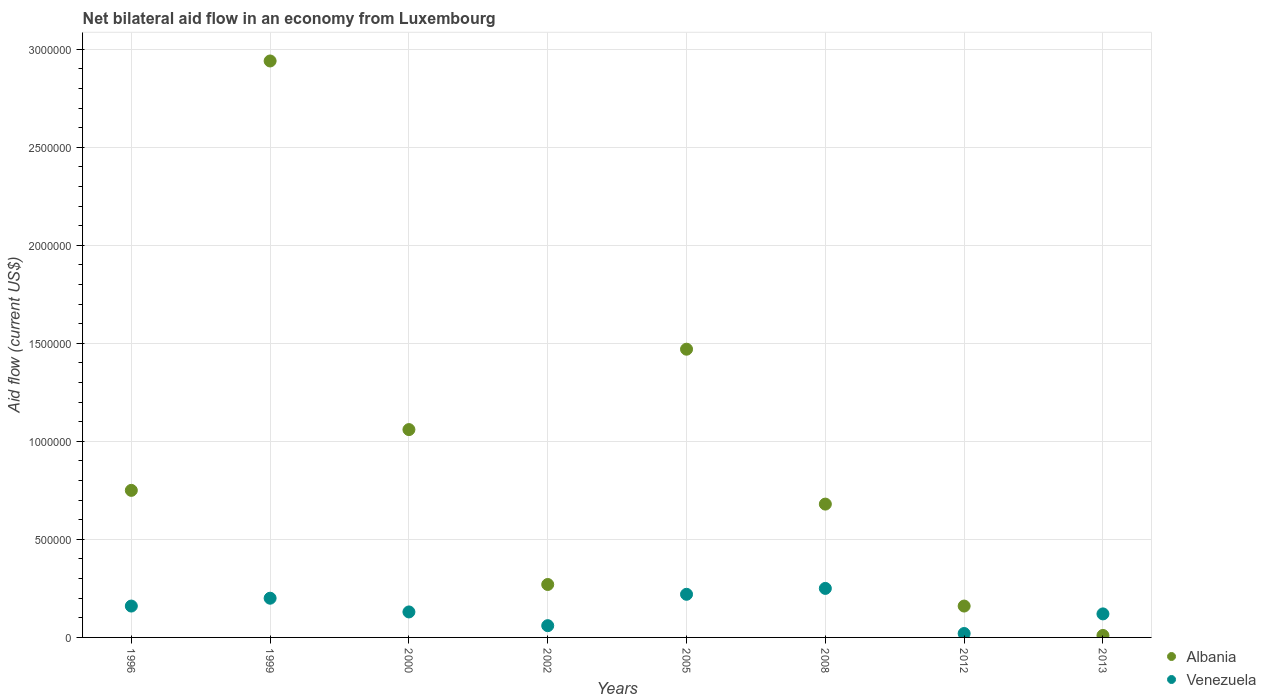How many different coloured dotlines are there?
Offer a very short reply. 2. What is the net bilateral aid flow in Venezuela in 2000?
Offer a terse response. 1.30e+05. Across all years, what is the maximum net bilateral aid flow in Albania?
Offer a terse response. 2.94e+06. In which year was the net bilateral aid flow in Venezuela minimum?
Your answer should be very brief. 2012. What is the total net bilateral aid flow in Venezuela in the graph?
Offer a very short reply. 1.16e+06. What is the difference between the net bilateral aid flow in Albania in 1999 and that in 2013?
Keep it short and to the point. 2.93e+06. What is the average net bilateral aid flow in Venezuela per year?
Make the answer very short. 1.45e+05. In the year 2005, what is the difference between the net bilateral aid flow in Venezuela and net bilateral aid flow in Albania?
Your response must be concise. -1.25e+06. What is the ratio of the net bilateral aid flow in Albania in 1999 to that in 2000?
Your response must be concise. 2.77. Is the net bilateral aid flow in Venezuela in 2002 less than that in 2008?
Ensure brevity in your answer.  Yes. What is the difference between the highest and the second highest net bilateral aid flow in Venezuela?
Provide a short and direct response. 3.00e+04. In how many years, is the net bilateral aid flow in Venezuela greater than the average net bilateral aid flow in Venezuela taken over all years?
Offer a very short reply. 4. Is the sum of the net bilateral aid flow in Venezuela in 2008 and 2012 greater than the maximum net bilateral aid flow in Albania across all years?
Offer a very short reply. No. Does the net bilateral aid flow in Albania monotonically increase over the years?
Give a very brief answer. No. Is the net bilateral aid flow in Venezuela strictly greater than the net bilateral aid flow in Albania over the years?
Make the answer very short. No. Is the net bilateral aid flow in Albania strictly less than the net bilateral aid flow in Venezuela over the years?
Your answer should be very brief. No. Are the values on the major ticks of Y-axis written in scientific E-notation?
Your answer should be compact. No. What is the title of the graph?
Offer a terse response. Net bilateral aid flow in an economy from Luxembourg. Does "Korea (Democratic)" appear as one of the legend labels in the graph?
Your answer should be compact. No. What is the label or title of the X-axis?
Make the answer very short. Years. What is the Aid flow (current US$) in Albania in 1996?
Ensure brevity in your answer.  7.50e+05. What is the Aid flow (current US$) in Venezuela in 1996?
Keep it short and to the point. 1.60e+05. What is the Aid flow (current US$) of Albania in 1999?
Your response must be concise. 2.94e+06. What is the Aid flow (current US$) in Venezuela in 1999?
Give a very brief answer. 2.00e+05. What is the Aid flow (current US$) of Albania in 2000?
Provide a short and direct response. 1.06e+06. What is the Aid flow (current US$) in Venezuela in 2000?
Make the answer very short. 1.30e+05. What is the Aid flow (current US$) of Venezuela in 2002?
Provide a succinct answer. 6.00e+04. What is the Aid flow (current US$) of Albania in 2005?
Your answer should be compact. 1.47e+06. What is the Aid flow (current US$) of Albania in 2008?
Give a very brief answer. 6.80e+05. What is the Aid flow (current US$) in Albania in 2012?
Make the answer very short. 1.60e+05. What is the Aid flow (current US$) of Venezuela in 2012?
Ensure brevity in your answer.  2.00e+04. What is the Aid flow (current US$) of Albania in 2013?
Your response must be concise. 10000. What is the Aid flow (current US$) of Venezuela in 2013?
Your answer should be very brief. 1.20e+05. Across all years, what is the maximum Aid flow (current US$) in Albania?
Provide a short and direct response. 2.94e+06. Across all years, what is the minimum Aid flow (current US$) in Albania?
Offer a terse response. 10000. What is the total Aid flow (current US$) of Albania in the graph?
Offer a very short reply. 7.34e+06. What is the total Aid flow (current US$) of Venezuela in the graph?
Keep it short and to the point. 1.16e+06. What is the difference between the Aid flow (current US$) of Albania in 1996 and that in 1999?
Your answer should be compact. -2.19e+06. What is the difference between the Aid flow (current US$) in Venezuela in 1996 and that in 1999?
Give a very brief answer. -4.00e+04. What is the difference between the Aid flow (current US$) in Albania in 1996 and that in 2000?
Your answer should be very brief. -3.10e+05. What is the difference between the Aid flow (current US$) in Albania in 1996 and that in 2005?
Your answer should be very brief. -7.20e+05. What is the difference between the Aid flow (current US$) of Venezuela in 1996 and that in 2008?
Give a very brief answer. -9.00e+04. What is the difference between the Aid flow (current US$) in Albania in 1996 and that in 2012?
Your answer should be very brief. 5.90e+05. What is the difference between the Aid flow (current US$) of Venezuela in 1996 and that in 2012?
Your answer should be compact. 1.40e+05. What is the difference between the Aid flow (current US$) in Albania in 1996 and that in 2013?
Offer a terse response. 7.40e+05. What is the difference between the Aid flow (current US$) of Albania in 1999 and that in 2000?
Make the answer very short. 1.88e+06. What is the difference between the Aid flow (current US$) in Venezuela in 1999 and that in 2000?
Provide a succinct answer. 7.00e+04. What is the difference between the Aid flow (current US$) in Albania in 1999 and that in 2002?
Ensure brevity in your answer.  2.67e+06. What is the difference between the Aid flow (current US$) of Albania in 1999 and that in 2005?
Offer a very short reply. 1.47e+06. What is the difference between the Aid flow (current US$) in Albania in 1999 and that in 2008?
Make the answer very short. 2.26e+06. What is the difference between the Aid flow (current US$) in Venezuela in 1999 and that in 2008?
Give a very brief answer. -5.00e+04. What is the difference between the Aid flow (current US$) in Albania in 1999 and that in 2012?
Offer a very short reply. 2.78e+06. What is the difference between the Aid flow (current US$) in Venezuela in 1999 and that in 2012?
Your answer should be compact. 1.80e+05. What is the difference between the Aid flow (current US$) in Albania in 1999 and that in 2013?
Ensure brevity in your answer.  2.93e+06. What is the difference between the Aid flow (current US$) of Albania in 2000 and that in 2002?
Your answer should be compact. 7.90e+05. What is the difference between the Aid flow (current US$) of Venezuela in 2000 and that in 2002?
Give a very brief answer. 7.00e+04. What is the difference between the Aid flow (current US$) of Albania in 2000 and that in 2005?
Your answer should be very brief. -4.10e+05. What is the difference between the Aid flow (current US$) of Venezuela in 2000 and that in 2008?
Your response must be concise. -1.20e+05. What is the difference between the Aid flow (current US$) of Albania in 2000 and that in 2013?
Provide a succinct answer. 1.05e+06. What is the difference between the Aid flow (current US$) of Albania in 2002 and that in 2005?
Your answer should be compact. -1.20e+06. What is the difference between the Aid flow (current US$) of Albania in 2002 and that in 2008?
Keep it short and to the point. -4.10e+05. What is the difference between the Aid flow (current US$) of Albania in 2002 and that in 2012?
Your answer should be very brief. 1.10e+05. What is the difference between the Aid flow (current US$) in Venezuela in 2002 and that in 2012?
Ensure brevity in your answer.  4.00e+04. What is the difference between the Aid flow (current US$) in Albania in 2002 and that in 2013?
Offer a terse response. 2.60e+05. What is the difference between the Aid flow (current US$) in Albania in 2005 and that in 2008?
Keep it short and to the point. 7.90e+05. What is the difference between the Aid flow (current US$) in Albania in 2005 and that in 2012?
Offer a very short reply. 1.31e+06. What is the difference between the Aid flow (current US$) of Albania in 2005 and that in 2013?
Provide a short and direct response. 1.46e+06. What is the difference between the Aid flow (current US$) of Albania in 2008 and that in 2012?
Offer a terse response. 5.20e+05. What is the difference between the Aid flow (current US$) in Albania in 2008 and that in 2013?
Give a very brief answer. 6.70e+05. What is the difference between the Aid flow (current US$) of Albania in 1996 and the Aid flow (current US$) of Venezuela in 2000?
Your answer should be very brief. 6.20e+05. What is the difference between the Aid flow (current US$) in Albania in 1996 and the Aid flow (current US$) in Venezuela in 2002?
Offer a very short reply. 6.90e+05. What is the difference between the Aid flow (current US$) in Albania in 1996 and the Aid flow (current US$) in Venezuela in 2005?
Your response must be concise. 5.30e+05. What is the difference between the Aid flow (current US$) in Albania in 1996 and the Aid flow (current US$) in Venezuela in 2008?
Provide a short and direct response. 5.00e+05. What is the difference between the Aid flow (current US$) of Albania in 1996 and the Aid flow (current US$) of Venezuela in 2012?
Give a very brief answer. 7.30e+05. What is the difference between the Aid flow (current US$) of Albania in 1996 and the Aid flow (current US$) of Venezuela in 2013?
Make the answer very short. 6.30e+05. What is the difference between the Aid flow (current US$) in Albania in 1999 and the Aid flow (current US$) in Venezuela in 2000?
Provide a succinct answer. 2.81e+06. What is the difference between the Aid flow (current US$) in Albania in 1999 and the Aid flow (current US$) in Venezuela in 2002?
Provide a succinct answer. 2.88e+06. What is the difference between the Aid flow (current US$) of Albania in 1999 and the Aid flow (current US$) of Venezuela in 2005?
Keep it short and to the point. 2.72e+06. What is the difference between the Aid flow (current US$) in Albania in 1999 and the Aid flow (current US$) in Venezuela in 2008?
Your response must be concise. 2.69e+06. What is the difference between the Aid flow (current US$) of Albania in 1999 and the Aid flow (current US$) of Venezuela in 2012?
Offer a very short reply. 2.92e+06. What is the difference between the Aid flow (current US$) in Albania in 1999 and the Aid flow (current US$) in Venezuela in 2013?
Offer a terse response. 2.82e+06. What is the difference between the Aid flow (current US$) in Albania in 2000 and the Aid flow (current US$) in Venezuela in 2005?
Offer a very short reply. 8.40e+05. What is the difference between the Aid flow (current US$) of Albania in 2000 and the Aid flow (current US$) of Venezuela in 2008?
Give a very brief answer. 8.10e+05. What is the difference between the Aid flow (current US$) in Albania in 2000 and the Aid flow (current US$) in Venezuela in 2012?
Your answer should be compact. 1.04e+06. What is the difference between the Aid flow (current US$) in Albania in 2000 and the Aid flow (current US$) in Venezuela in 2013?
Your answer should be very brief. 9.40e+05. What is the difference between the Aid flow (current US$) in Albania in 2002 and the Aid flow (current US$) in Venezuela in 2005?
Make the answer very short. 5.00e+04. What is the difference between the Aid flow (current US$) of Albania in 2002 and the Aid flow (current US$) of Venezuela in 2008?
Provide a short and direct response. 2.00e+04. What is the difference between the Aid flow (current US$) in Albania in 2002 and the Aid flow (current US$) in Venezuela in 2012?
Keep it short and to the point. 2.50e+05. What is the difference between the Aid flow (current US$) of Albania in 2005 and the Aid flow (current US$) of Venezuela in 2008?
Offer a terse response. 1.22e+06. What is the difference between the Aid flow (current US$) in Albania in 2005 and the Aid flow (current US$) in Venezuela in 2012?
Your answer should be compact. 1.45e+06. What is the difference between the Aid flow (current US$) in Albania in 2005 and the Aid flow (current US$) in Venezuela in 2013?
Offer a very short reply. 1.35e+06. What is the difference between the Aid flow (current US$) in Albania in 2008 and the Aid flow (current US$) in Venezuela in 2012?
Make the answer very short. 6.60e+05. What is the difference between the Aid flow (current US$) of Albania in 2008 and the Aid flow (current US$) of Venezuela in 2013?
Offer a very short reply. 5.60e+05. What is the average Aid flow (current US$) in Albania per year?
Make the answer very short. 9.18e+05. What is the average Aid flow (current US$) of Venezuela per year?
Your answer should be compact. 1.45e+05. In the year 1996, what is the difference between the Aid flow (current US$) of Albania and Aid flow (current US$) of Venezuela?
Provide a short and direct response. 5.90e+05. In the year 1999, what is the difference between the Aid flow (current US$) of Albania and Aid flow (current US$) of Venezuela?
Provide a short and direct response. 2.74e+06. In the year 2000, what is the difference between the Aid flow (current US$) in Albania and Aid flow (current US$) in Venezuela?
Make the answer very short. 9.30e+05. In the year 2002, what is the difference between the Aid flow (current US$) of Albania and Aid flow (current US$) of Venezuela?
Offer a terse response. 2.10e+05. In the year 2005, what is the difference between the Aid flow (current US$) in Albania and Aid flow (current US$) in Venezuela?
Keep it short and to the point. 1.25e+06. In the year 2013, what is the difference between the Aid flow (current US$) in Albania and Aid flow (current US$) in Venezuela?
Give a very brief answer. -1.10e+05. What is the ratio of the Aid flow (current US$) in Albania in 1996 to that in 1999?
Offer a terse response. 0.26. What is the ratio of the Aid flow (current US$) of Venezuela in 1996 to that in 1999?
Your answer should be very brief. 0.8. What is the ratio of the Aid flow (current US$) in Albania in 1996 to that in 2000?
Your response must be concise. 0.71. What is the ratio of the Aid flow (current US$) of Venezuela in 1996 to that in 2000?
Make the answer very short. 1.23. What is the ratio of the Aid flow (current US$) in Albania in 1996 to that in 2002?
Ensure brevity in your answer.  2.78. What is the ratio of the Aid flow (current US$) of Venezuela in 1996 to that in 2002?
Offer a terse response. 2.67. What is the ratio of the Aid flow (current US$) of Albania in 1996 to that in 2005?
Your answer should be compact. 0.51. What is the ratio of the Aid flow (current US$) in Venezuela in 1996 to that in 2005?
Your response must be concise. 0.73. What is the ratio of the Aid flow (current US$) in Albania in 1996 to that in 2008?
Your response must be concise. 1.1. What is the ratio of the Aid flow (current US$) of Venezuela in 1996 to that in 2008?
Give a very brief answer. 0.64. What is the ratio of the Aid flow (current US$) in Albania in 1996 to that in 2012?
Keep it short and to the point. 4.69. What is the ratio of the Aid flow (current US$) of Albania in 1999 to that in 2000?
Your answer should be compact. 2.77. What is the ratio of the Aid flow (current US$) of Venezuela in 1999 to that in 2000?
Make the answer very short. 1.54. What is the ratio of the Aid flow (current US$) in Albania in 1999 to that in 2002?
Provide a short and direct response. 10.89. What is the ratio of the Aid flow (current US$) of Albania in 1999 to that in 2005?
Your answer should be compact. 2. What is the ratio of the Aid flow (current US$) of Venezuela in 1999 to that in 2005?
Your response must be concise. 0.91. What is the ratio of the Aid flow (current US$) in Albania in 1999 to that in 2008?
Offer a very short reply. 4.32. What is the ratio of the Aid flow (current US$) in Albania in 1999 to that in 2012?
Keep it short and to the point. 18.38. What is the ratio of the Aid flow (current US$) of Albania in 1999 to that in 2013?
Ensure brevity in your answer.  294. What is the ratio of the Aid flow (current US$) of Albania in 2000 to that in 2002?
Your answer should be compact. 3.93. What is the ratio of the Aid flow (current US$) in Venezuela in 2000 to that in 2002?
Offer a very short reply. 2.17. What is the ratio of the Aid flow (current US$) of Albania in 2000 to that in 2005?
Provide a succinct answer. 0.72. What is the ratio of the Aid flow (current US$) in Venezuela in 2000 to that in 2005?
Ensure brevity in your answer.  0.59. What is the ratio of the Aid flow (current US$) in Albania in 2000 to that in 2008?
Make the answer very short. 1.56. What is the ratio of the Aid flow (current US$) of Venezuela in 2000 to that in 2008?
Ensure brevity in your answer.  0.52. What is the ratio of the Aid flow (current US$) in Albania in 2000 to that in 2012?
Your response must be concise. 6.62. What is the ratio of the Aid flow (current US$) in Venezuela in 2000 to that in 2012?
Your answer should be very brief. 6.5. What is the ratio of the Aid flow (current US$) in Albania in 2000 to that in 2013?
Provide a succinct answer. 106. What is the ratio of the Aid flow (current US$) of Venezuela in 2000 to that in 2013?
Your response must be concise. 1.08. What is the ratio of the Aid flow (current US$) in Albania in 2002 to that in 2005?
Your answer should be very brief. 0.18. What is the ratio of the Aid flow (current US$) in Venezuela in 2002 to that in 2005?
Make the answer very short. 0.27. What is the ratio of the Aid flow (current US$) in Albania in 2002 to that in 2008?
Keep it short and to the point. 0.4. What is the ratio of the Aid flow (current US$) of Venezuela in 2002 to that in 2008?
Make the answer very short. 0.24. What is the ratio of the Aid flow (current US$) in Albania in 2002 to that in 2012?
Ensure brevity in your answer.  1.69. What is the ratio of the Aid flow (current US$) in Albania in 2002 to that in 2013?
Your answer should be very brief. 27. What is the ratio of the Aid flow (current US$) of Venezuela in 2002 to that in 2013?
Offer a very short reply. 0.5. What is the ratio of the Aid flow (current US$) of Albania in 2005 to that in 2008?
Give a very brief answer. 2.16. What is the ratio of the Aid flow (current US$) of Venezuela in 2005 to that in 2008?
Offer a very short reply. 0.88. What is the ratio of the Aid flow (current US$) of Albania in 2005 to that in 2012?
Offer a terse response. 9.19. What is the ratio of the Aid flow (current US$) of Venezuela in 2005 to that in 2012?
Your answer should be very brief. 11. What is the ratio of the Aid flow (current US$) of Albania in 2005 to that in 2013?
Keep it short and to the point. 147. What is the ratio of the Aid flow (current US$) in Venezuela in 2005 to that in 2013?
Your answer should be very brief. 1.83. What is the ratio of the Aid flow (current US$) in Albania in 2008 to that in 2012?
Your answer should be very brief. 4.25. What is the ratio of the Aid flow (current US$) in Albania in 2008 to that in 2013?
Keep it short and to the point. 68. What is the ratio of the Aid flow (current US$) of Venezuela in 2008 to that in 2013?
Your answer should be compact. 2.08. What is the ratio of the Aid flow (current US$) of Albania in 2012 to that in 2013?
Provide a short and direct response. 16. What is the ratio of the Aid flow (current US$) in Venezuela in 2012 to that in 2013?
Your answer should be very brief. 0.17. What is the difference between the highest and the second highest Aid flow (current US$) in Albania?
Keep it short and to the point. 1.47e+06. What is the difference between the highest and the second highest Aid flow (current US$) in Venezuela?
Ensure brevity in your answer.  3.00e+04. What is the difference between the highest and the lowest Aid flow (current US$) of Albania?
Your answer should be compact. 2.93e+06. What is the difference between the highest and the lowest Aid flow (current US$) of Venezuela?
Provide a succinct answer. 2.30e+05. 